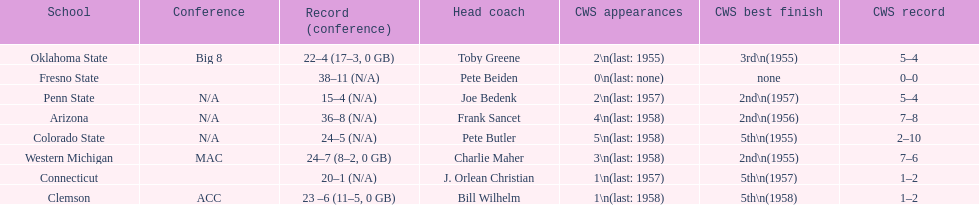List each of the schools that came in 2nd for cws best finish. Arizona, Penn State, Western Michigan. 